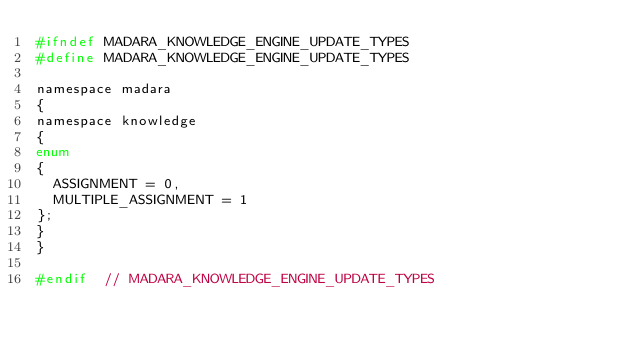Convert code to text. <code><loc_0><loc_0><loc_500><loc_500><_C_>#ifndef MADARA_KNOWLEDGE_ENGINE_UPDATE_TYPES
#define MADARA_KNOWLEDGE_ENGINE_UPDATE_TYPES

namespace madara
{
namespace knowledge
{
enum
{
  ASSIGNMENT = 0,
  MULTIPLE_ASSIGNMENT = 1
};
}
}

#endif  // MADARA_KNOWLEDGE_ENGINE_UPDATE_TYPES
</code> 